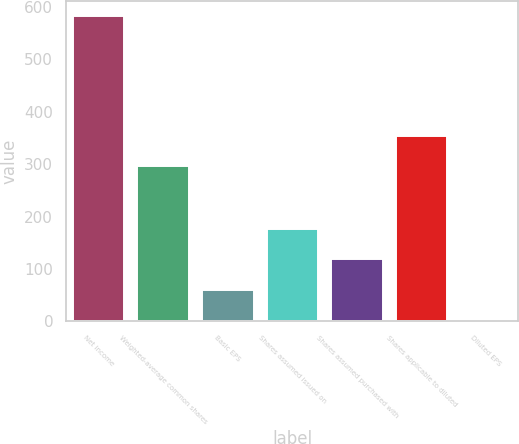Convert chart to OTSL. <chart><loc_0><loc_0><loc_500><loc_500><bar_chart><fcel>Net income<fcel>Weighted-average common shares<fcel>Basic EPS<fcel>Shares assumed issued on<fcel>Shares assumed purchased with<fcel>Shares applicable to diluted<fcel>Diluted EPS<nl><fcel>583<fcel>296<fcel>59.99<fcel>176.21<fcel>118.1<fcel>354.11<fcel>1.88<nl></chart> 